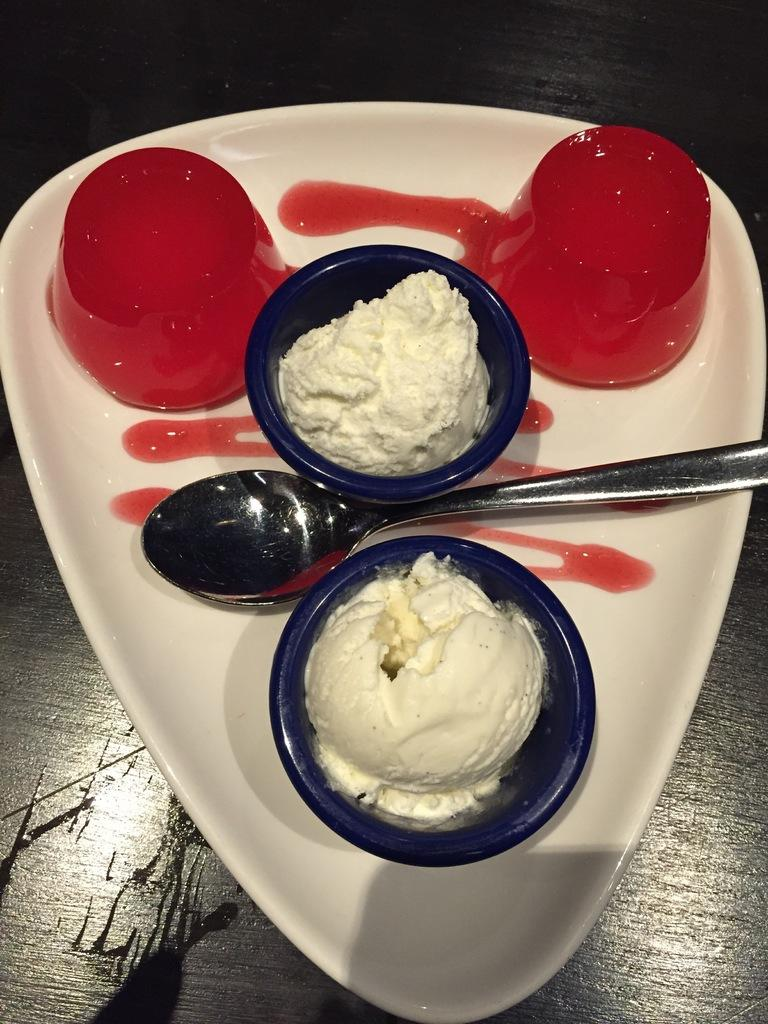What utensil can be seen in the image? There is a spoon in the image. What type of dishware is present in the image? There are bowls in the image. What is the color of the plate that holds food items? The plate is white. Where is the plate located in the image? The plate is placed on a surface. Can you describe the zephyr blowing through the food items on the plate? There is no zephyr present in the image, and therefore no such wind can be observed. 